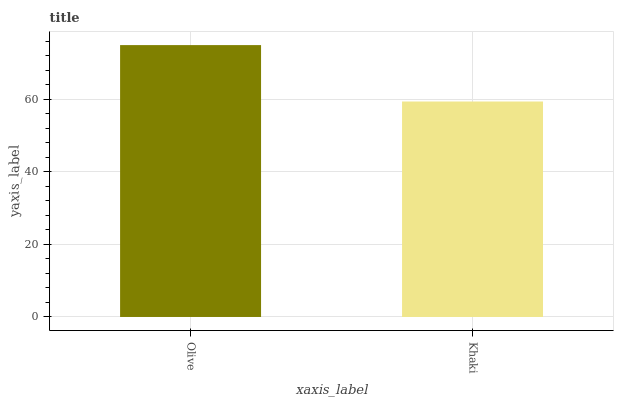Is Khaki the minimum?
Answer yes or no. Yes. Is Olive the maximum?
Answer yes or no. Yes. Is Khaki the maximum?
Answer yes or no. No. Is Olive greater than Khaki?
Answer yes or no. Yes. Is Khaki less than Olive?
Answer yes or no. Yes. Is Khaki greater than Olive?
Answer yes or no. No. Is Olive less than Khaki?
Answer yes or no. No. Is Olive the high median?
Answer yes or no. Yes. Is Khaki the low median?
Answer yes or no. Yes. Is Khaki the high median?
Answer yes or no. No. Is Olive the low median?
Answer yes or no. No. 